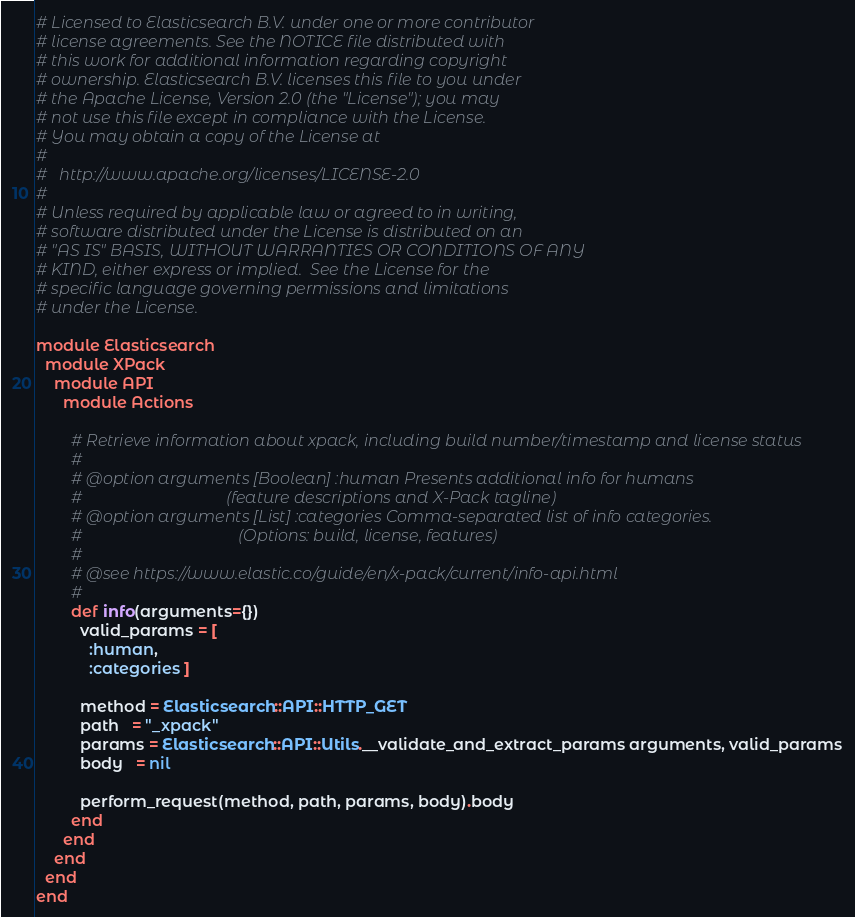Convert code to text. <code><loc_0><loc_0><loc_500><loc_500><_Ruby_># Licensed to Elasticsearch B.V. under one or more contributor
# license agreements. See the NOTICE file distributed with
# this work for additional information regarding copyright
# ownership. Elasticsearch B.V. licenses this file to you under
# the Apache License, Version 2.0 (the "License"); you may
# not use this file except in compliance with the License.
# You may obtain a copy of the License at
#
#	http://www.apache.org/licenses/LICENSE-2.0
#
# Unless required by applicable law or agreed to in writing,
# software distributed under the License is distributed on an
# "AS IS" BASIS, WITHOUT WARRANTIES OR CONDITIONS OF ANY
# KIND, either express or implied.  See the License for the
# specific language governing permissions and limitations
# under the License.

module Elasticsearch
  module XPack
    module API
      module Actions

        # Retrieve information about xpack, including build number/timestamp and license status
        #
        # @option arguments [Boolean] :human Presents additional info for humans
        #                                   (feature descriptions and X-Pack tagline)
        # @option arguments [List] :categories Comma-separated list of info categories.
        #                                      (Options: build, license, features)
        #
        # @see https://www.elastic.co/guide/en/x-pack/current/info-api.html
        #
        def info(arguments={})
          valid_params = [
            :human,
            :categories ]

          method = Elasticsearch::API::HTTP_GET
          path   = "_xpack"
          params = Elasticsearch::API::Utils.__validate_and_extract_params arguments, valid_params
          body   = nil

          perform_request(method, path, params, body).body
        end
      end
    end
  end
end
</code> 